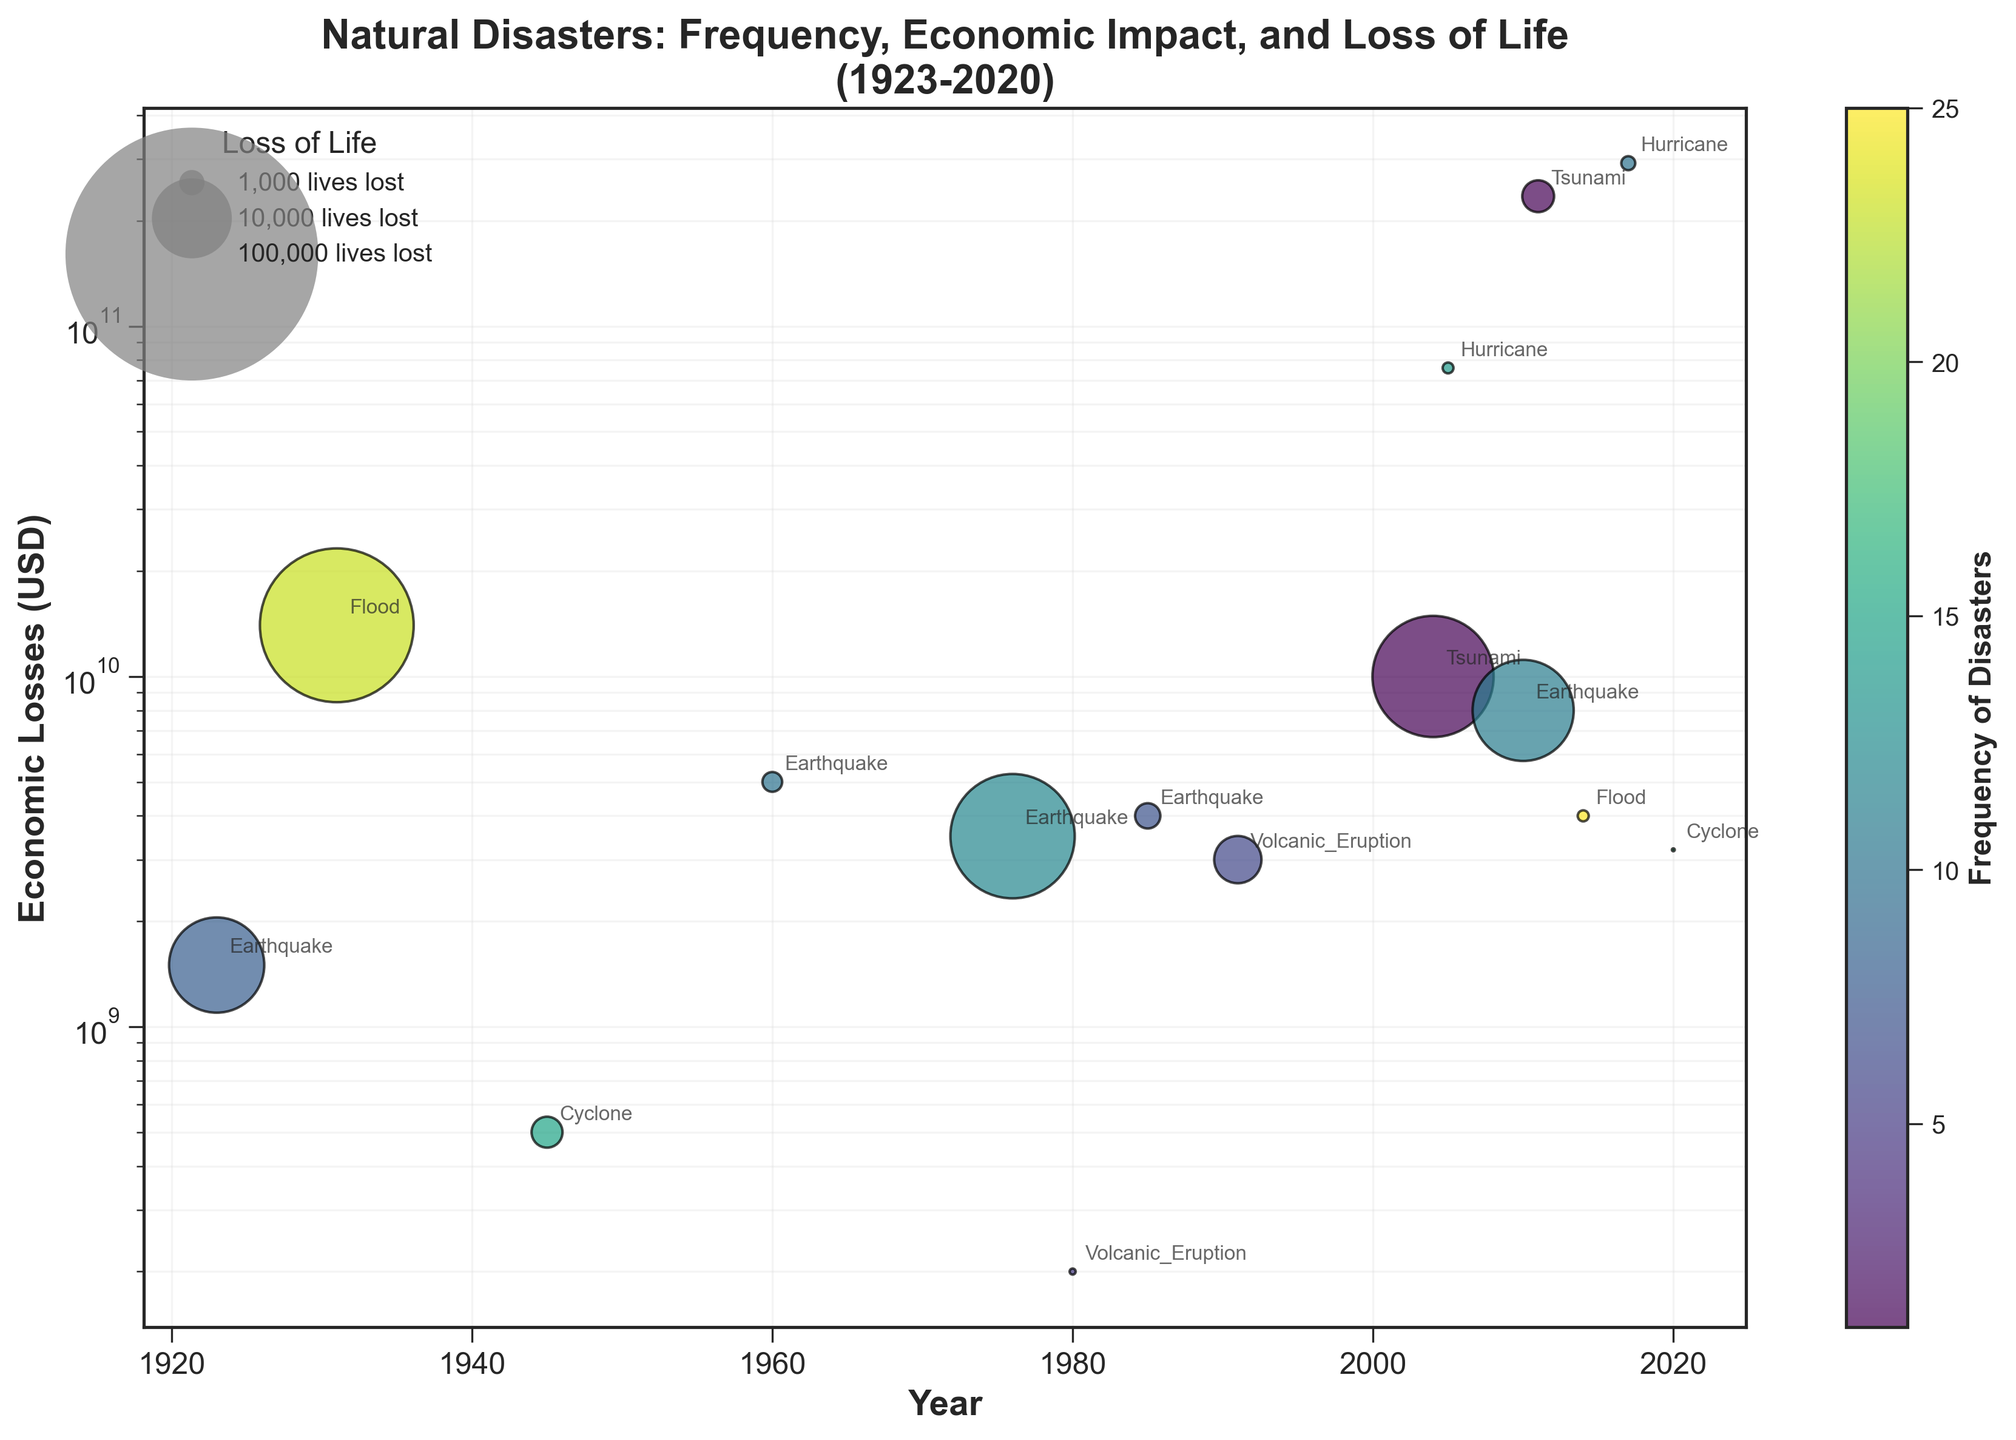How does the frequency of natural disasters relate to their economic impact in this figure? To find this, observe the color of the scatter points (representing frequency) and their position on the y-axis (representing economic impact). More frequent events are shown in lighter colors, and high economic impacts are high on the y-axis. We can see certain points with high frequency (lighter colors) still aligning with both low and high economic impacts.
Answer: Variable relationship What's the highest economic loss recorded and in which year and disaster type did it occur? The highest economic loss can be found by locating the highest point on the y-axis. The point closest to the top of the y-axis represents the highest economic loss. According to the annotated figure, this is around 2011 caused by a Tsunami.
Answer: 235 billion USD, 2011, Tsunami How does the impact on loss of life correlate with economic losses in natural disasters? The size of the scatter points represents the impact on the loss of life, and their y-axis position represents economic losses. Larger scatter points indicate higher loss of life and vice versa. We can notice larger scatter points are distributed among varying economic losses. For instance, the 1923 earthquake shows high loss of life but relatively lower economic loss compared to modern disasters.
Answer: Varies Which disaster type appears most frequently in this dataset? Identify the points with similar annotations (disaster types) and count their frequencies. Floods appear the most frequently based on the annotations and the number of instances of each disaster type. By examining the figure, floods have multiple instances, especially around 1931 and 2014.
Answer: Flood What year did the earthquake with the highest economic impact occur? Find the "Earthquake" annotations and locate the highest economic impact among these points. The 2010 earthquake stands out with its high position on the y-axis.
Answer: 2010 Between 2000 and 2020, how many natural disasters had an economic impact exceeding 20 billion USD? Look at the range of years between 2000 and 2020 on the x-axis and check the scatter points in this range above the 20 billion USD mark on the y-axis. There are two such points: one in 2005 (Hurricane) and one in 2011 (Tsunami).
Answer: Two How does log scale help interpret the economic impact of natural disasters over this period? The log scale allows us to visualize a wide range of economic impacts more clearly, indicating even small differences in lower values and large differences in higher values effectively. Disparate data points become easier to compare.
Answer: Easier comparison Comparing the floods of 1931 and 2014, which one had higher economic losses and what is the approximate difference? Observing the positions of the points for floods in 1931 and 2014 on the y-axis, the 1931 flood is higher, indicating greater economic losses. The difference is between approximately 14 billion USD (1931) and 4 billion USD (2014). Subtract 4 billion from 14 billion for the difference.
Answer: 1931, 10 billion USD Considering natural disasters due to Tsunamis, which was more severe in terms of economic losses: the 2004 or 2011 tsunami? Compare the y-axis positions for the points labeled "Tsunami" in 2004 and 'Tsunami' in 2011. The 2011 Tsunami is significantly higher on the y-axis (235 billion USD) compared to the 2004 Tsunami (10 billion USD).
Answer: 2011 